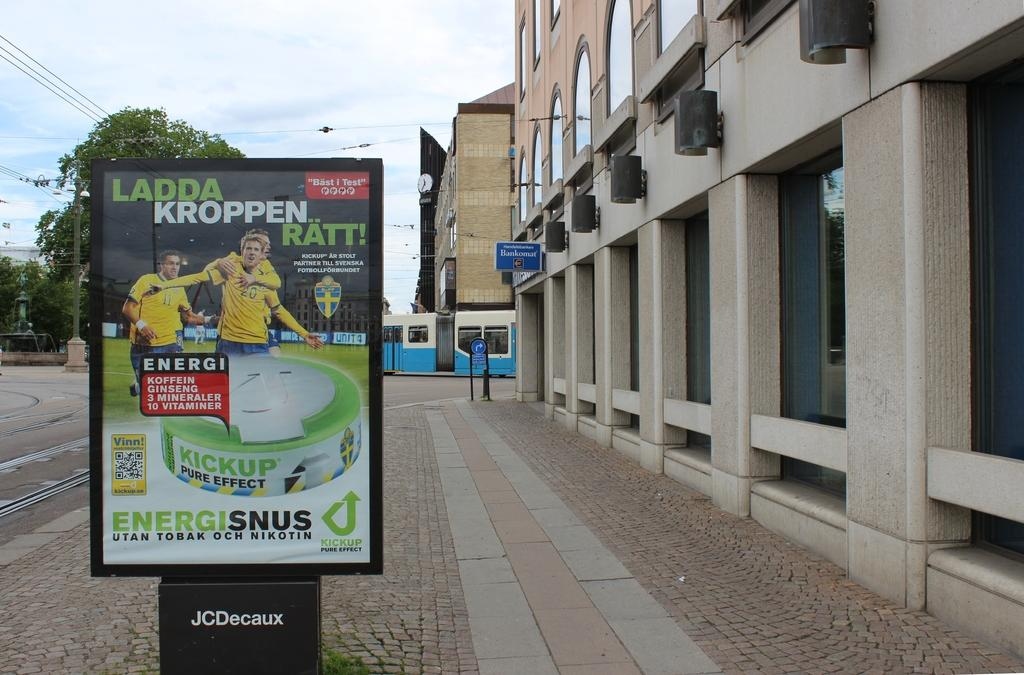Provide a one-sentence caption for the provided image. Ladda Kroppen sign for enegisinus on a board outside. 